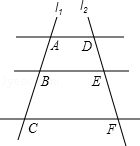What can this diagram represent in a geometrical context? The diagram can represent several geometry concepts, such as transversal lines, angle relationships, and coordinates in a plane. If we consider line l1 as a transversal intersecting parallel lines l2 labeled with points D, E, and F, then this could be a demonstration of alternate interior angles, corresponding angles, and the concept of transversality in geometry. 